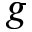Convert formula to latex. <formula><loc_0><loc_0><loc_500><loc_500>g</formula> 